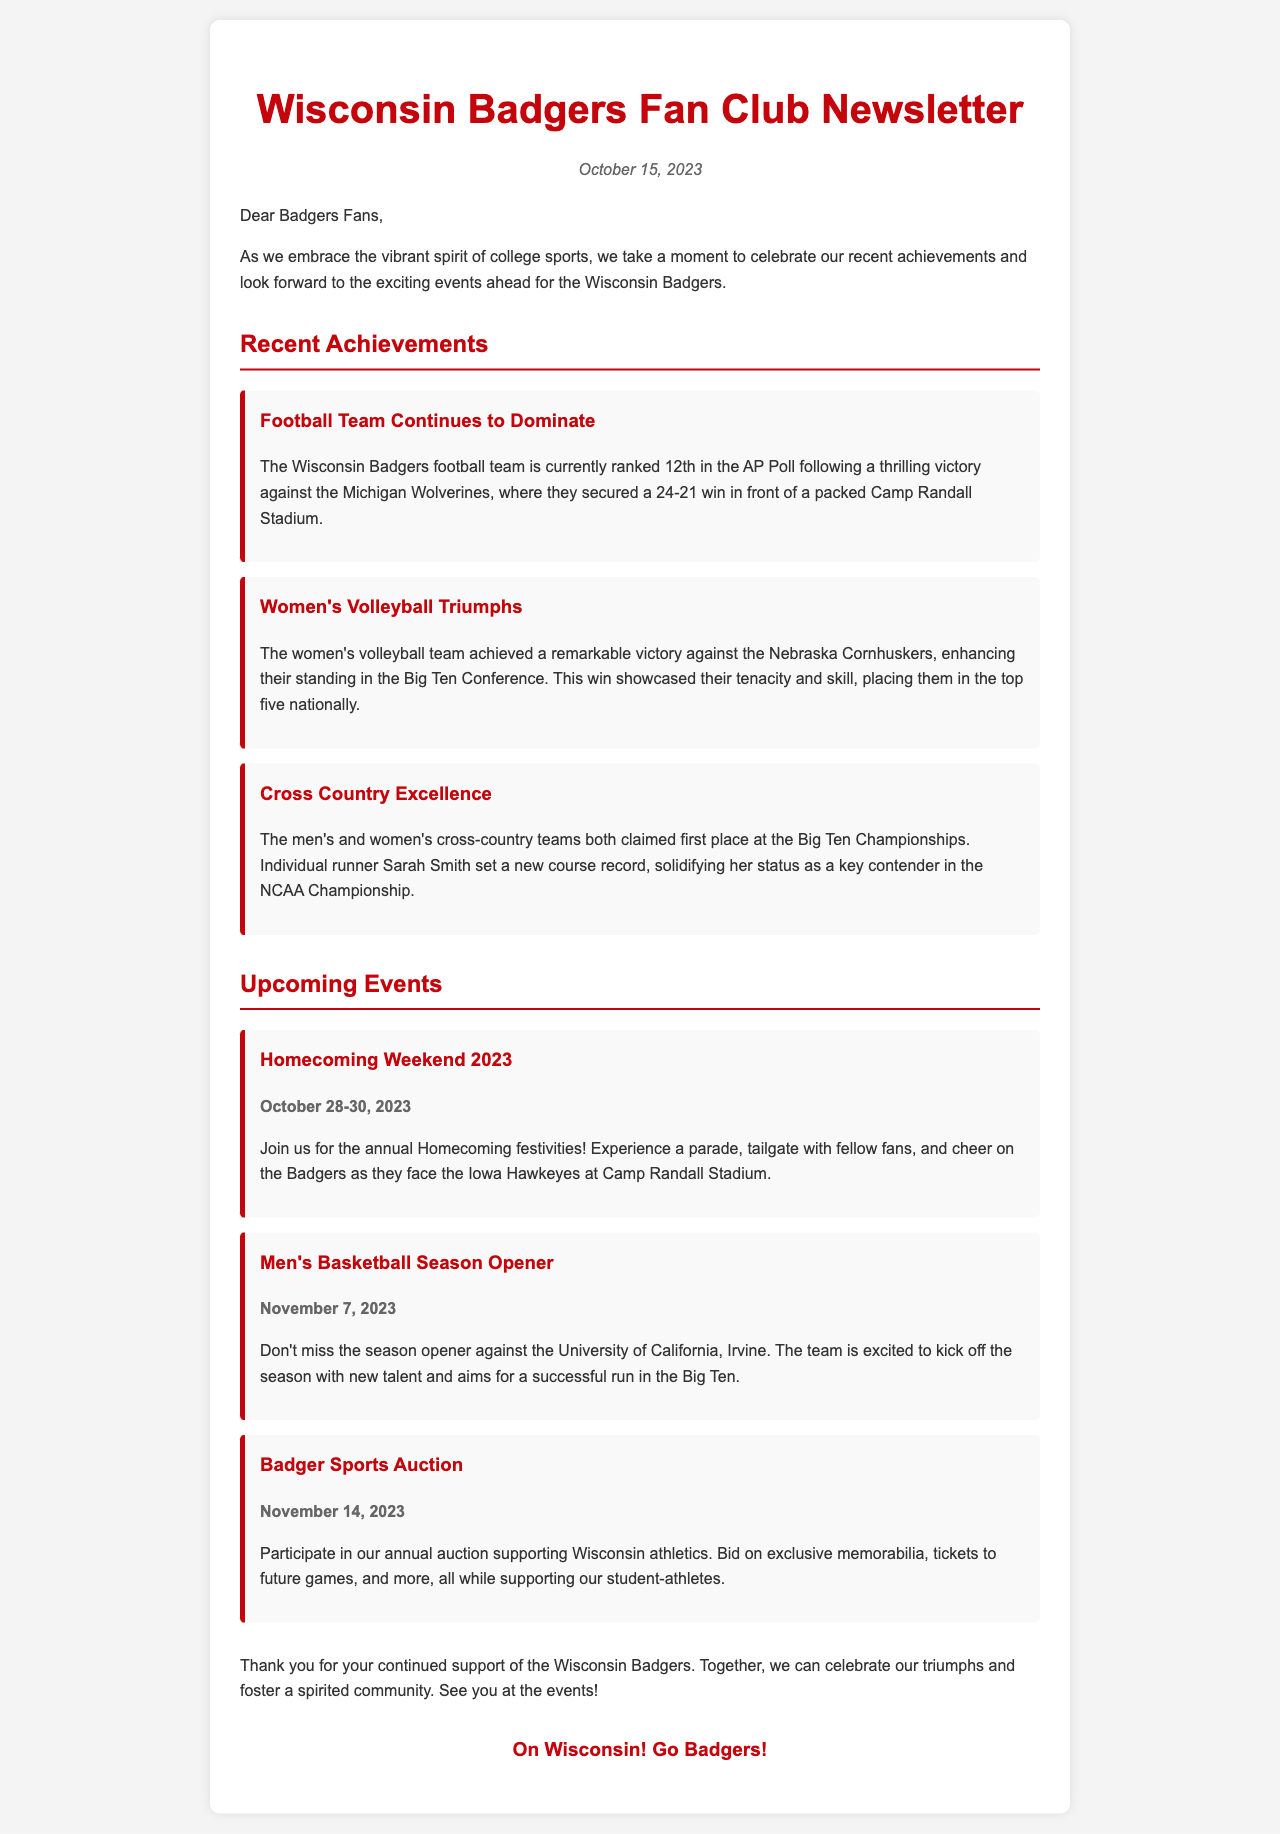What is the date of the newsletter? The date of the newsletter is mentioned at the top of the document.
Answer: October 15, 2023 Which team achieved a victory against the Nebraska Cornhuskers? This information is provided in the section highlighting recent achievements.
Answer: Women's Volleyball What ranking is the football team currently holding? The document states the current ranking of the football team in the AP Poll.
Answer: 12th What event takes place from October 28-30, 2023? The document specifies the dates and details of the upcoming event.
Answer: Homecoming Weekend 2023 Who set a new course record in cross-country? This is mentioned under the achievements section related to the cross-country teams.
Answer: Sarah Smith What is the name of the men's basketball season opener opponent? The document lists the opponent in the upcoming basketball event.
Answer: University of California, Irvine How many upcoming events are listed in the newsletter? By counting the events mentioned in the document, we find this information.
Answer: Three What color is the header text for Badgers-related achievements? The color of the header text for achievements is specified in the design section of the HTML code.
Answer: Red 